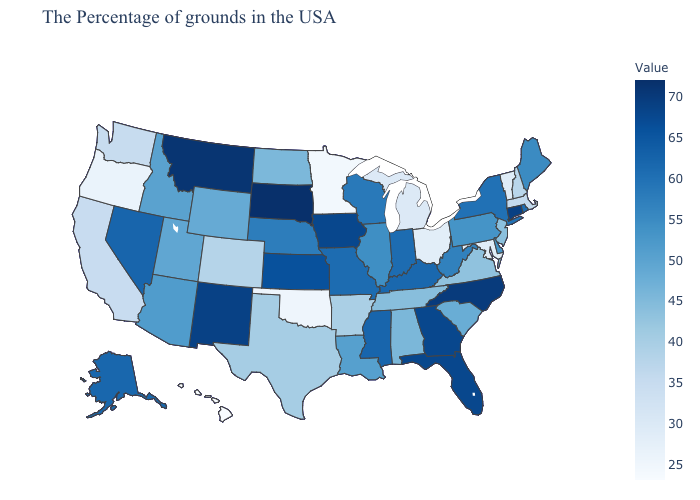Which states have the highest value in the USA?
Quick response, please. South Dakota. Is the legend a continuous bar?
Short answer required. Yes. Among the states that border Louisiana , does Arkansas have the lowest value?
Answer briefly. Yes. 